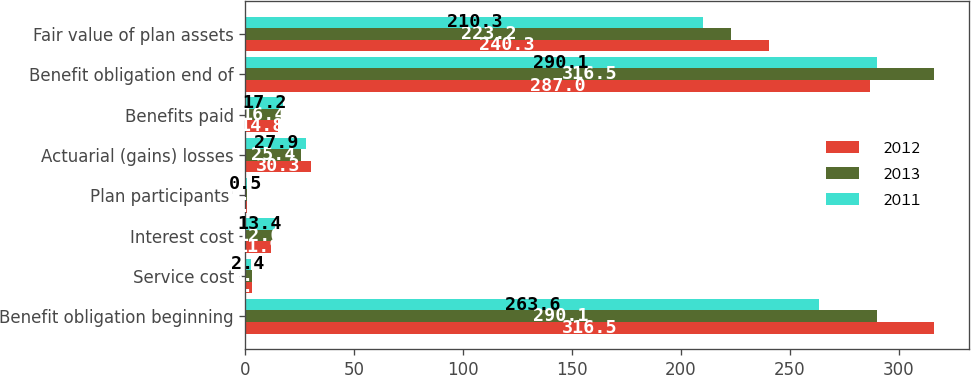Convert chart. <chart><loc_0><loc_0><loc_500><loc_500><stacked_bar_chart><ecel><fcel>Benefit obligation beginning<fcel>Service cost<fcel>Interest cost<fcel>Plan participants'<fcel>Actuarial (gains) losses<fcel>Benefits paid<fcel>Benefit obligation end of<fcel>Fair value of plan assets<nl><fcel>2012<fcel>316.5<fcel>3.2<fcel>11.9<fcel>0.5<fcel>30.3<fcel>14.8<fcel>287<fcel>240.3<nl><fcel>2013<fcel>290.1<fcel>3<fcel>12.6<fcel>0.5<fcel>25.4<fcel>16.4<fcel>316.5<fcel>223.2<nl><fcel>2011<fcel>263.6<fcel>2.4<fcel>13.4<fcel>0.5<fcel>27.9<fcel>17.2<fcel>290.1<fcel>210.3<nl></chart> 